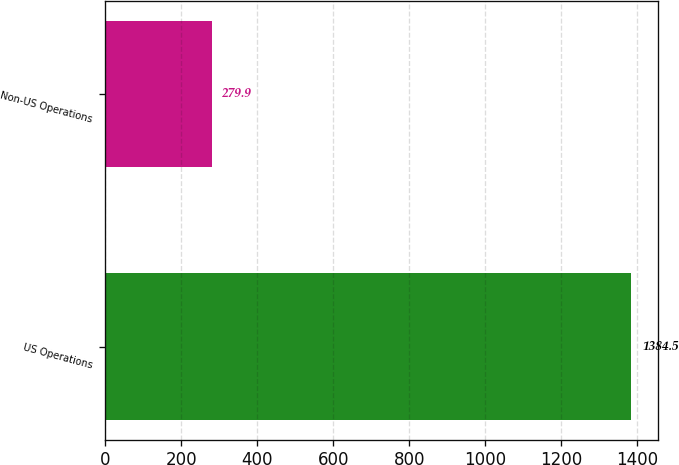Convert chart to OTSL. <chart><loc_0><loc_0><loc_500><loc_500><bar_chart><fcel>US Operations<fcel>Non-US Operations<nl><fcel>1384.5<fcel>279.9<nl></chart> 